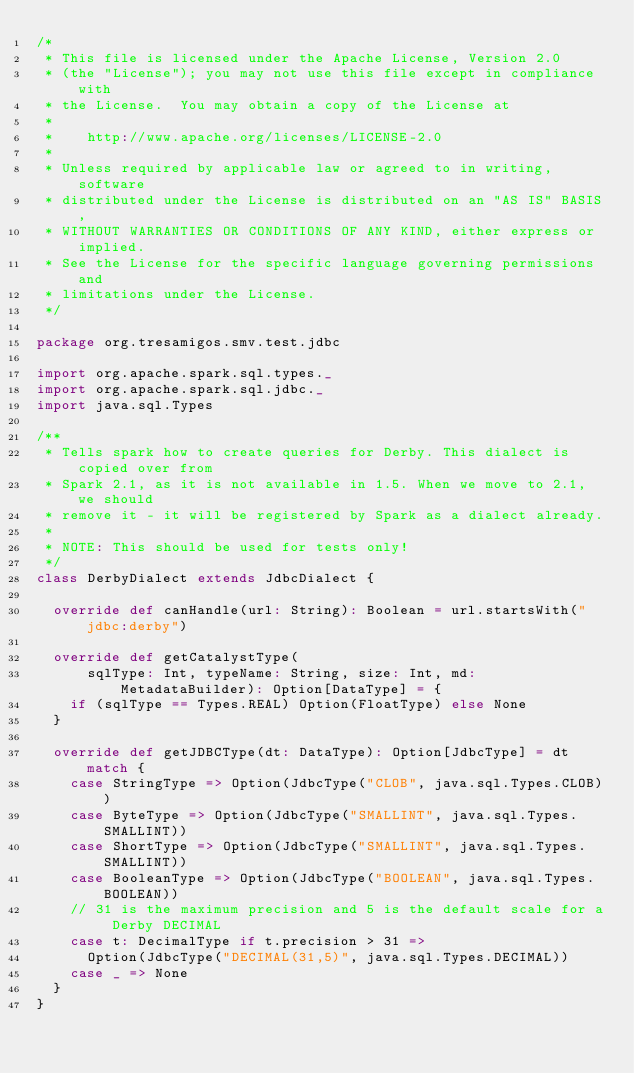<code> <loc_0><loc_0><loc_500><loc_500><_Scala_>/*
 * This file is licensed under the Apache License, Version 2.0
 * (the "License"); you may not use this file except in compliance with
 * the License.  You may obtain a copy of the License at
 *
 *    http://www.apache.org/licenses/LICENSE-2.0
 *
 * Unless required by applicable law or agreed to in writing, software
 * distributed under the License is distributed on an "AS IS" BASIS,
 * WITHOUT WARRANTIES OR CONDITIONS OF ANY KIND, either express or implied.
 * See the License for the specific language governing permissions and
 * limitations under the License.
 */

package org.tresamigos.smv.test.jdbc

import org.apache.spark.sql.types._
import org.apache.spark.sql.jdbc._
import java.sql.Types

/**
 * Tells spark how to create queries for Derby. This dialect is copied over from
 * Spark 2.1, as it is not available in 1.5. When we move to 2.1, we should
 * remove it - it will be registered by Spark as a dialect already.
 *
 * NOTE: This should be used for tests only!
 */
class DerbyDialect extends JdbcDialect {

  override def canHandle(url: String): Boolean = url.startsWith("jdbc:derby")

  override def getCatalystType(
      sqlType: Int, typeName: String, size: Int, md: MetadataBuilder): Option[DataType] = {
    if (sqlType == Types.REAL) Option(FloatType) else None
  }

  override def getJDBCType(dt: DataType): Option[JdbcType] = dt match {
    case StringType => Option(JdbcType("CLOB", java.sql.Types.CLOB))
    case ByteType => Option(JdbcType("SMALLINT", java.sql.Types.SMALLINT))
    case ShortType => Option(JdbcType("SMALLINT", java.sql.Types.SMALLINT))
    case BooleanType => Option(JdbcType("BOOLEAN", java.sql.Types.BOOLEAN))
    // 31 is the maximum precision and 5 is the default scale for a Derby DECIMAL
    case t: DecimalType if t.precision > 31 =>
      Option(JdbcType("DECIMAL(31,5)", java.sql.Types.DECIMAL))
    case _ => None
  }
}
</code> 